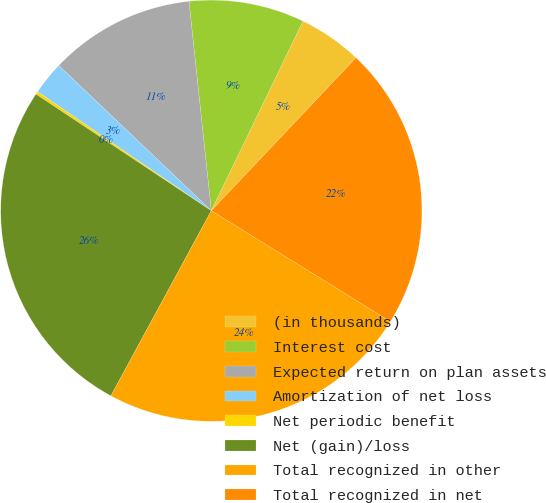Convert chart to OTSL. <chart><loc_0><loc_0><loc_500><loc_500><pie_chart><fcel>(in thousands)<fcel>Interest cost<fcel>Expected return on plan assets<fcel>Amortization of net loss<fcel>Net periodic benefit<fcel>Net (gain)/loss<fcel>Total recognized in other<fcel>Total recognized in net<nl><fcel>4.89%<fcel>8.86%<fcel>11.2%<fcel>2.55%<fcel>0.22%<fcel>26.43%<fcel>24.09%<fcel>21.76%<nl></chart> 